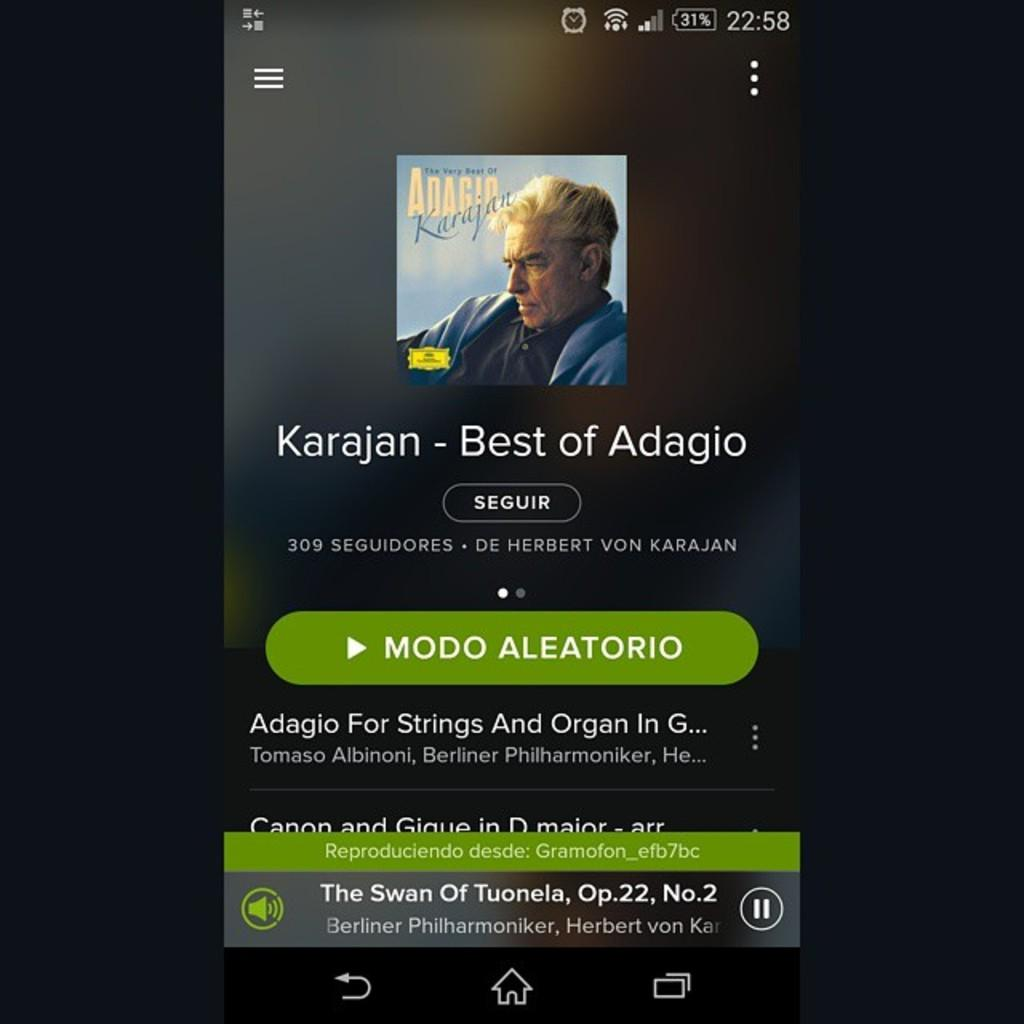<image>
Describe the image concisely. A smart device open to a page showing Karajan Best of Adagio. 